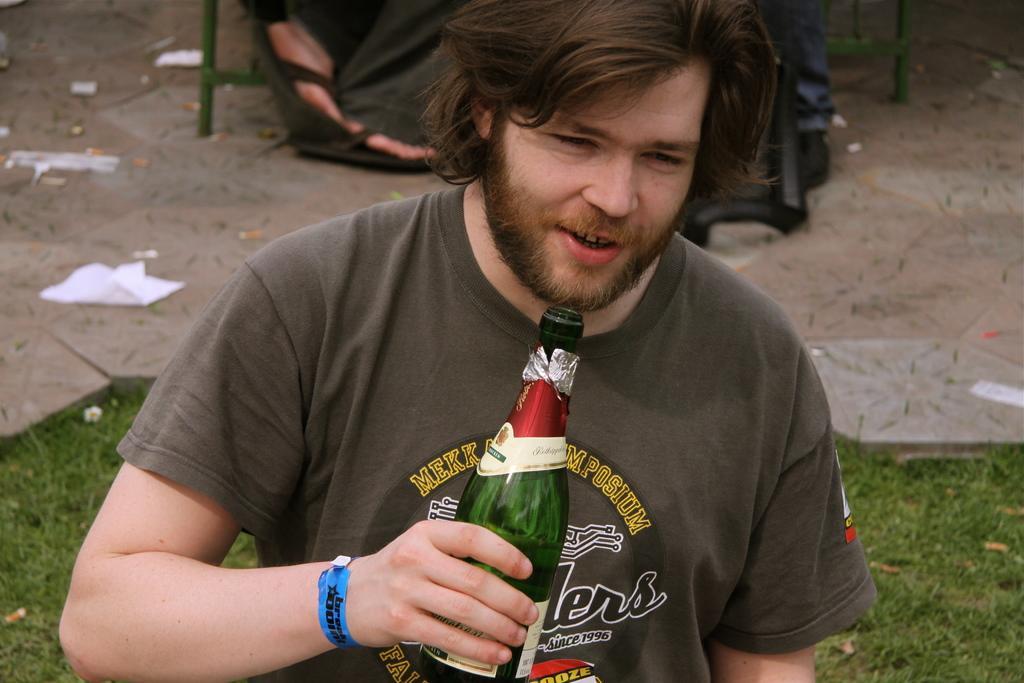Describe this image in one or two sentences. In this image i can see a person holding a bottle and his mouth is open and back side of him there are the legs of the person visible and there is a grass on the floor 